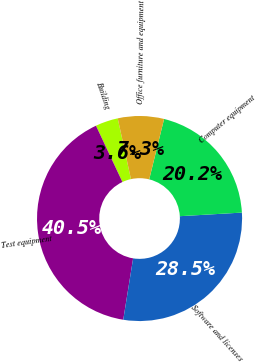<chart> <loc_0><loc_0><loc_500><loc_500><pie_chart><fcel>Building<fcel>Test equipment<fcel>Software and licenses<fcel>Computer equipment<fcel>Office furniture and equipment<nl><fcel>3.57%<fcel>40.47%<fcel>28.46%<fcel>20.23%<fcel>7.26%<nl></chart> 